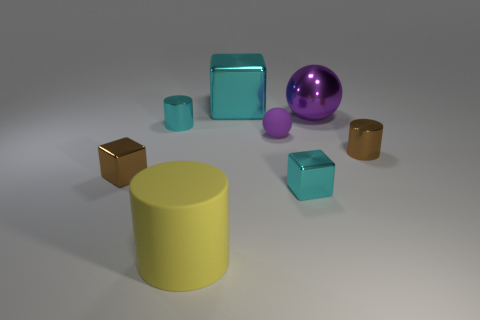How many purple balls must be subtracted to get 1 purple balls? 1 Add 1 brown cylinders. How many objects exist? 9 Subtract all cylinders. How many objects are left? 5 Subtract all red shiny things. Subtract all cyan metallic cylinders. How many objects are left? 7 Add 8 purple rubber balls. How many purple rubber balls are left? 9 Add 6 small gray spheres. How many small gray spheres exist? 6 Subtract 0 blue cubes. How many objects are left? 8 